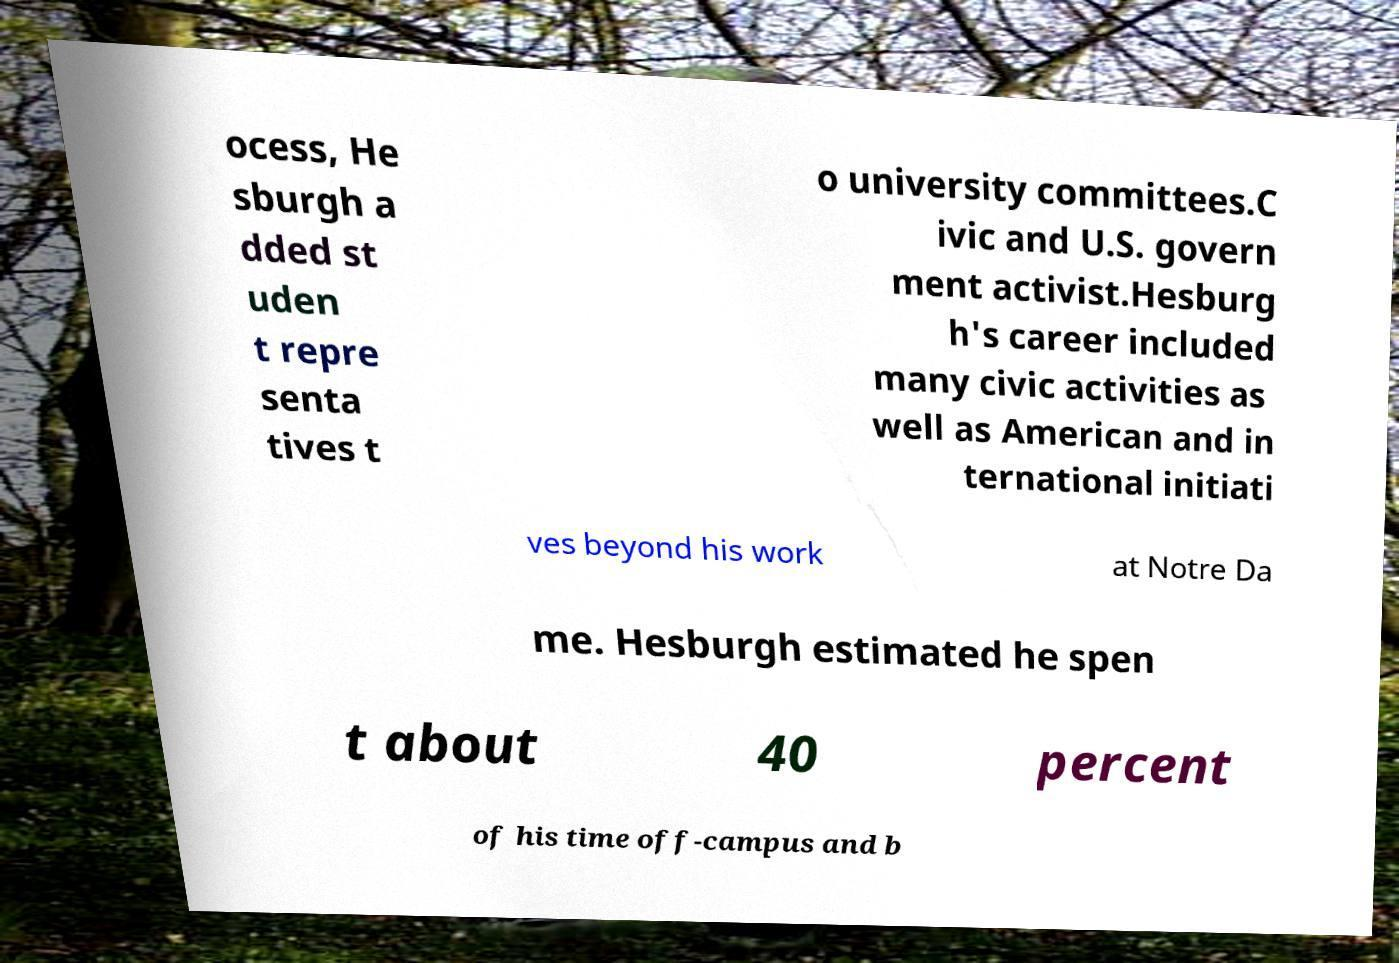Can you read and provide the text displayed in the image?This photo seems to have some interesting text. Can you extract and type it out for me? ocess, He sburgh a dded st uden t repre senta tives t o university committees.C ivic and U.S. govern ment activist.Hesburg h's career included many civic activities as well as American and in ternational initiati ves beyond his work at Notre Da me. Hesburgh estimated he spen t about 40 percent of his time off-campus and b 